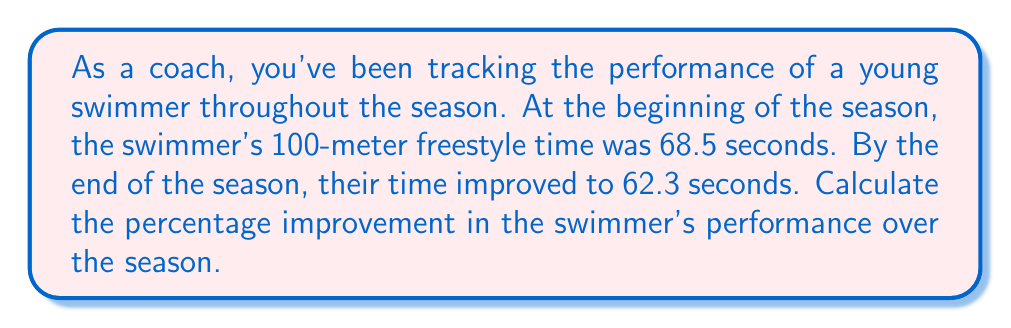What is the answer to this math problem? To calculate the percentage improvement, we need to follow these steps:

1. Calculate the difference in time:
   $\text{Time difference} = \text{Initial time} - \text{Final time}$
   $= 68.5 - 62.3 = 6.2$ seconds

2. Calculate the percentage improvement:
   $$\text{Percentage improvement} = \frac{\text{Time difference}}{\text{Initial time}} \times 100\%$$

   Substituting the values:
   $$\text{Percentage improvement} = \frac{6.2}{68.5} \times 100\%$$

3. Perform the division:
   $$\text{Percentage improvement} = 0.0905 \times 100\%$$

4. Convert to percentage:
   $$\text{Percentage improvement} = 9.05\%$$

The swimmer's performance improved by 9.05% over the season.
Answer: 9.05% 